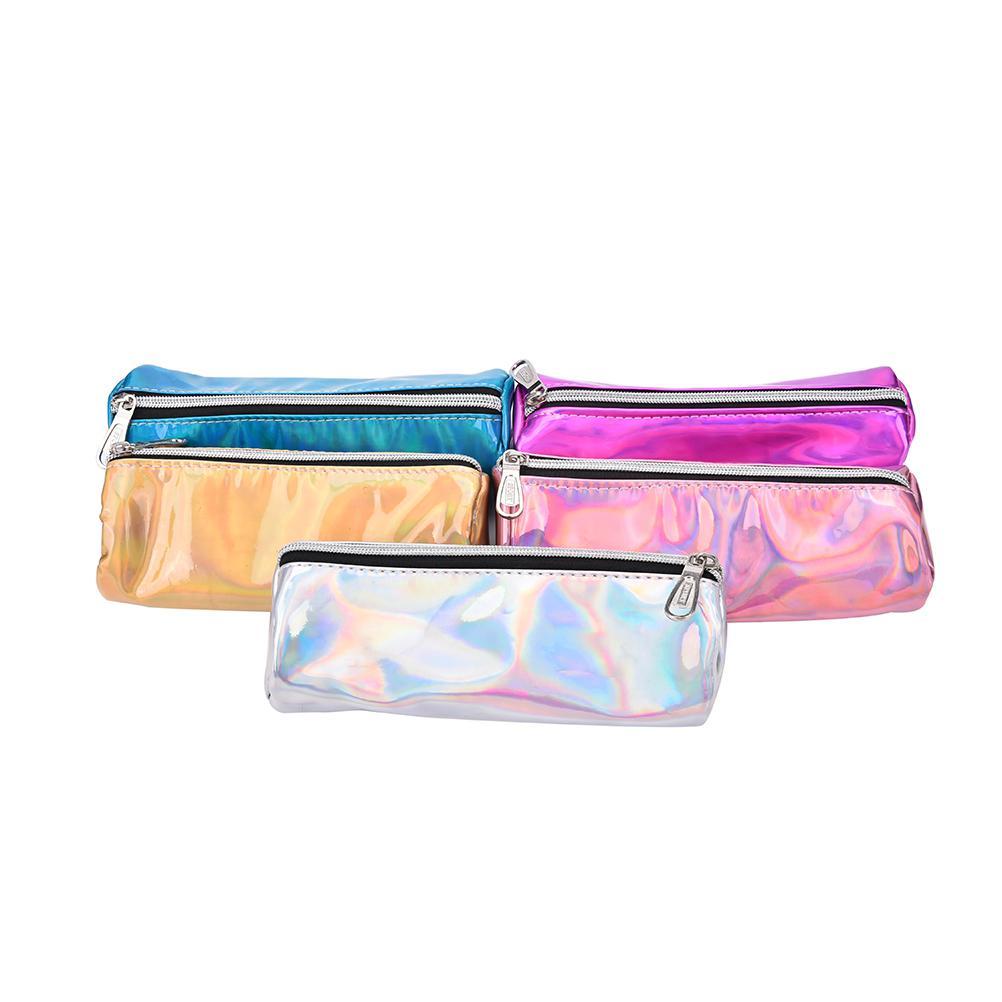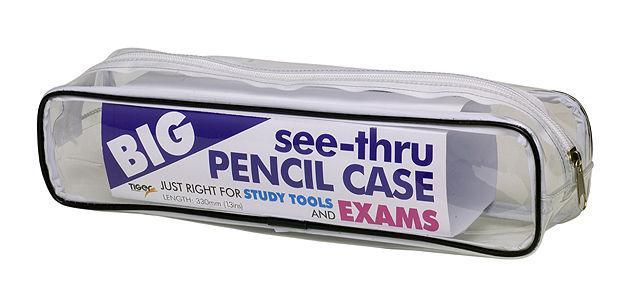The first image is the image on the left, the second image is the image on the right. For the images displayed, is the sentence "There are three pencil cases in at least one of the images." factually correct? Answer yes or no. No. The first image is the image on the left, the second image is the image on the right. Evaluate the accuracy of this statement regarding the images: "One pencil bag has a design.". Is it true? Answer yes or no. No. 